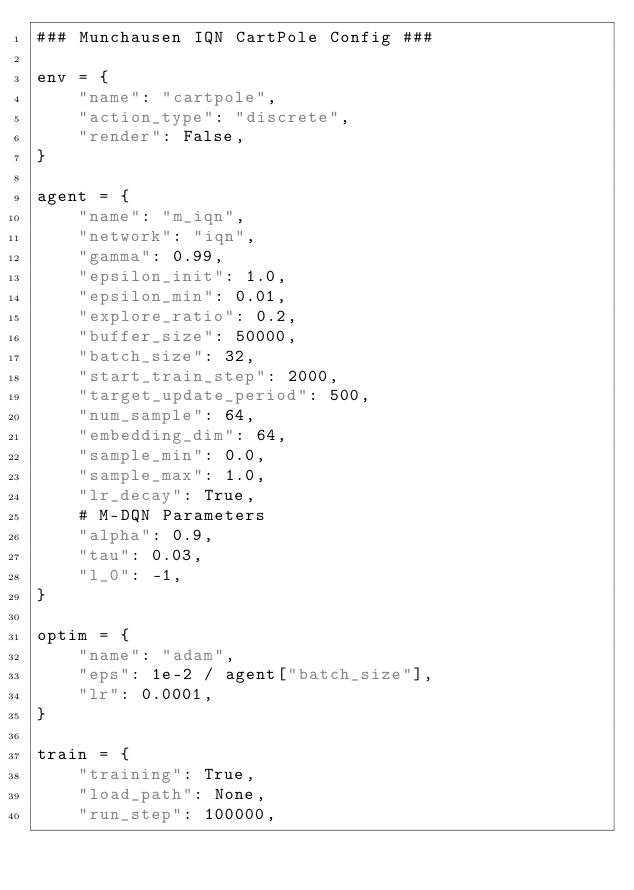Convert code to text. <code><loc_0><loc_0><loc_500><loc_500><_Python_>### Munchausen IQN CartPole Config ###

env = {
    "name": "cartpole",
    "action_type": "discrete",
    "render": False,
}

agent = {
    "name": "m_iqn",
    "network": "iqn",
    "gamma": 0.99,
    "epsilon_init": 1.0,
    "epsilon_min": 0.01,
    "explore_ratio": 0.2,
    "buffer_size": 50000,
    "batch_size": 32,
    "start_train_step": 2000,
    "target_update_period": 500,
    "num_sample": 64,
    "embedding_dim": 64,
    "sample_min": 0.0,
    "sample_max": 1.0,
    "lr_decay": True,
    # M-DQN Parameters
    "alpha": 0.9,
    "tau": 0.03,
    "l_0": -1,
}

optim = {
    "name": "adam",
    "eps": 1e-2 / agent["batch_size"],
    "lr": 0.0001,
}

train = {
    "training": True,
    "load_path": None,
    "run_step": 100000,</code> 